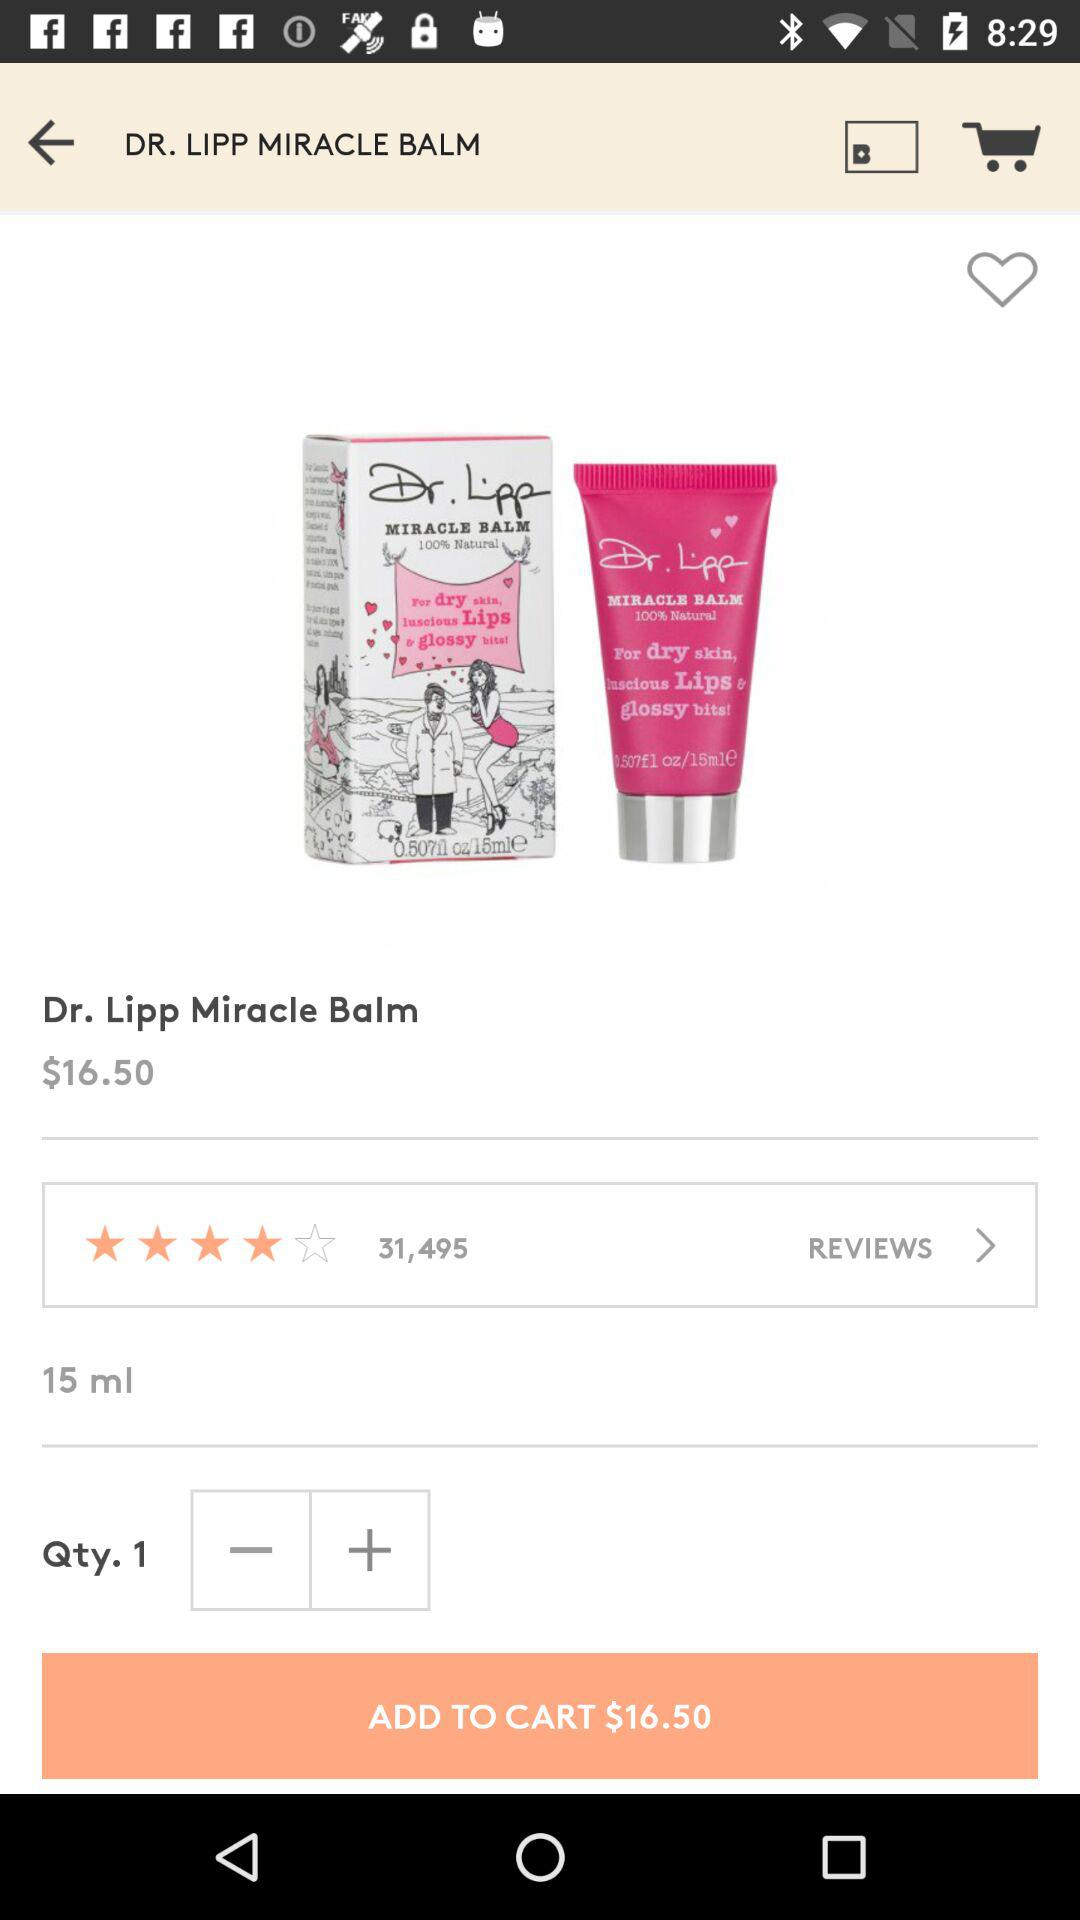What is the price of "Dr. Lipp Miracle Balm"? The price is $16.50. 